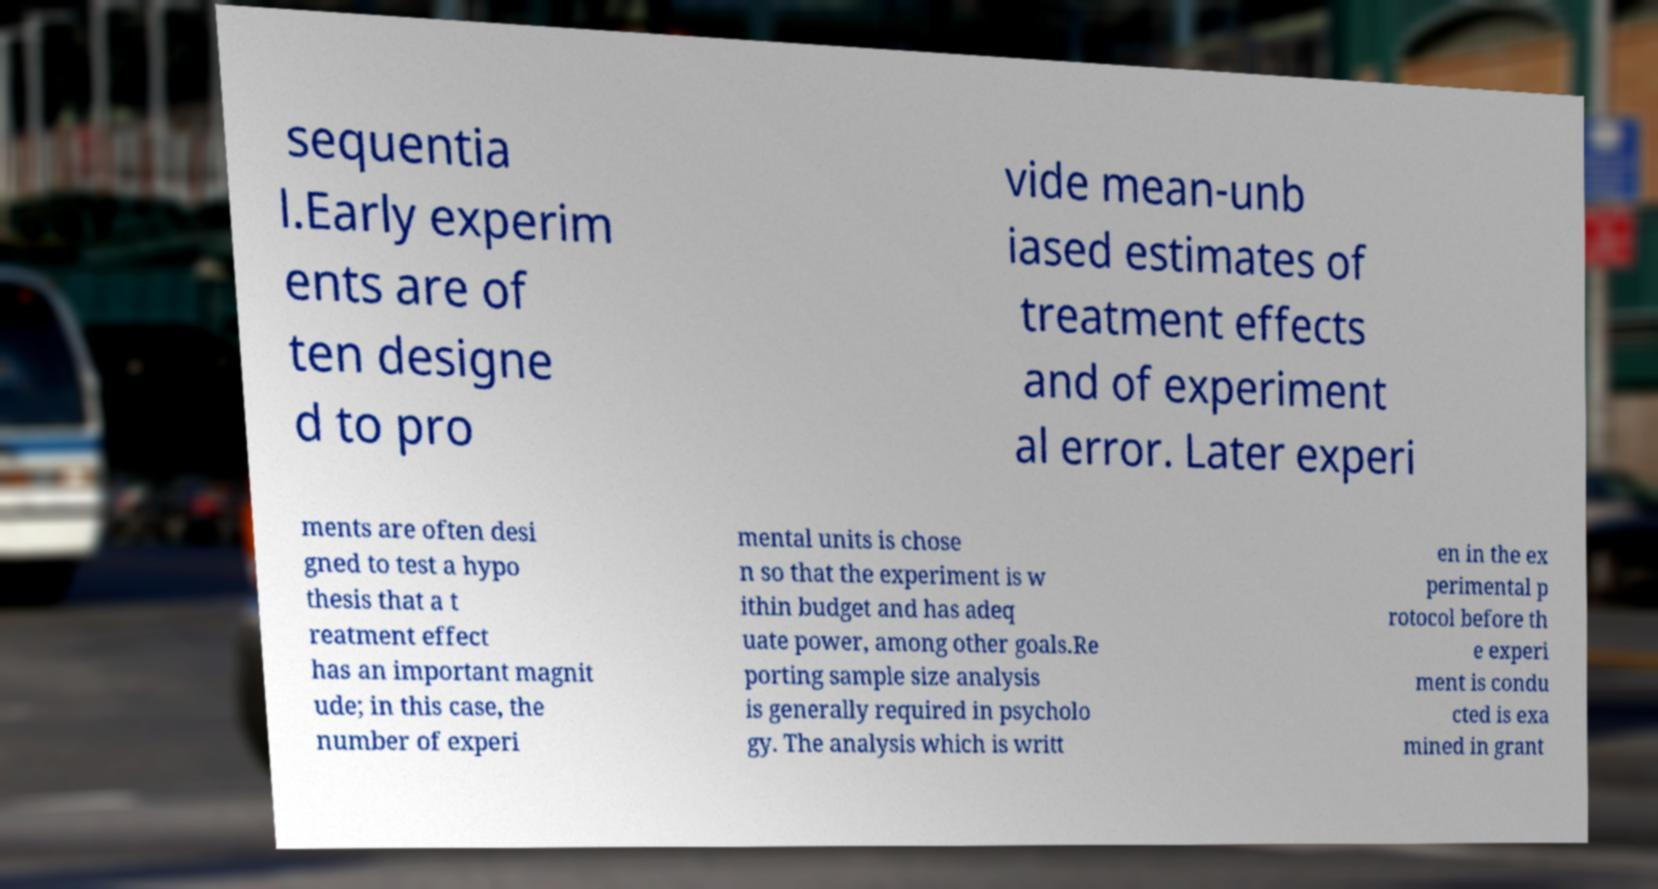Can you accurately transcribe the text from the provided image for me? sequentia l.Early experim ents are of ten designe d to pro vide mean-unb iased estimates of treatment effects and of experiment al error. Later experi ments are often desi gned to test a hypo thesis that a t reatment effect has an important magnit ude; in this case, the number of experi mental units is chose n so that the experiment is w ithin budget and has adeq uate power, among other goals.Re porting sample size analysis is generally required in psycholo gy. The analysis which is writt en in the ex perimental p rotocol before th e experi ment is condu cted is exa mined in grant 